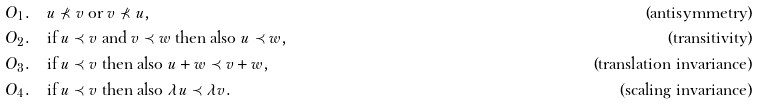<formula> <loc_0><loc_0><loc_500><loc_500>& O _ { 1 } . \quad \text {$u\not\prec v$ or $v\not\prec u$} , & \text {(antisymmetry)} & \\ & O _ { 2 } . \quad \text {if $u\prec v$ and $v\prec w$ then also $u\prec w$} , & \text {(transitivity)} & \\ & O _ { 3 } . \quad \text {if $u\prec v$ then also $u+w\prec v+w$} , & \text {(translation invariance)} & \\ & O _ { 4 } . \quad \text {if $u\prec v$ then also $\lambda u\prec \lambda v$} . & \text {(scaling invariance)}</formula> 